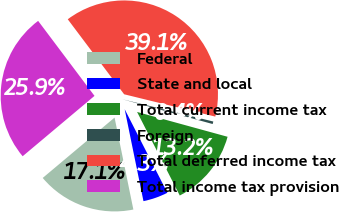Convert chart. <chart><loc_0><loc_0><loc_500><loc_500><pie_chart><fcel>Federal<fcel>State and local<fcel>Total current income tax<fcel>Foreign<fcel>Total deferred income tax<fcel>Total income tax provision<nl><fcel>17.09%<fcel>4.31%<fcel>13.22%<fcel>0.44%<fcel>39.08%<fcel>25.86%<nl></chart> 